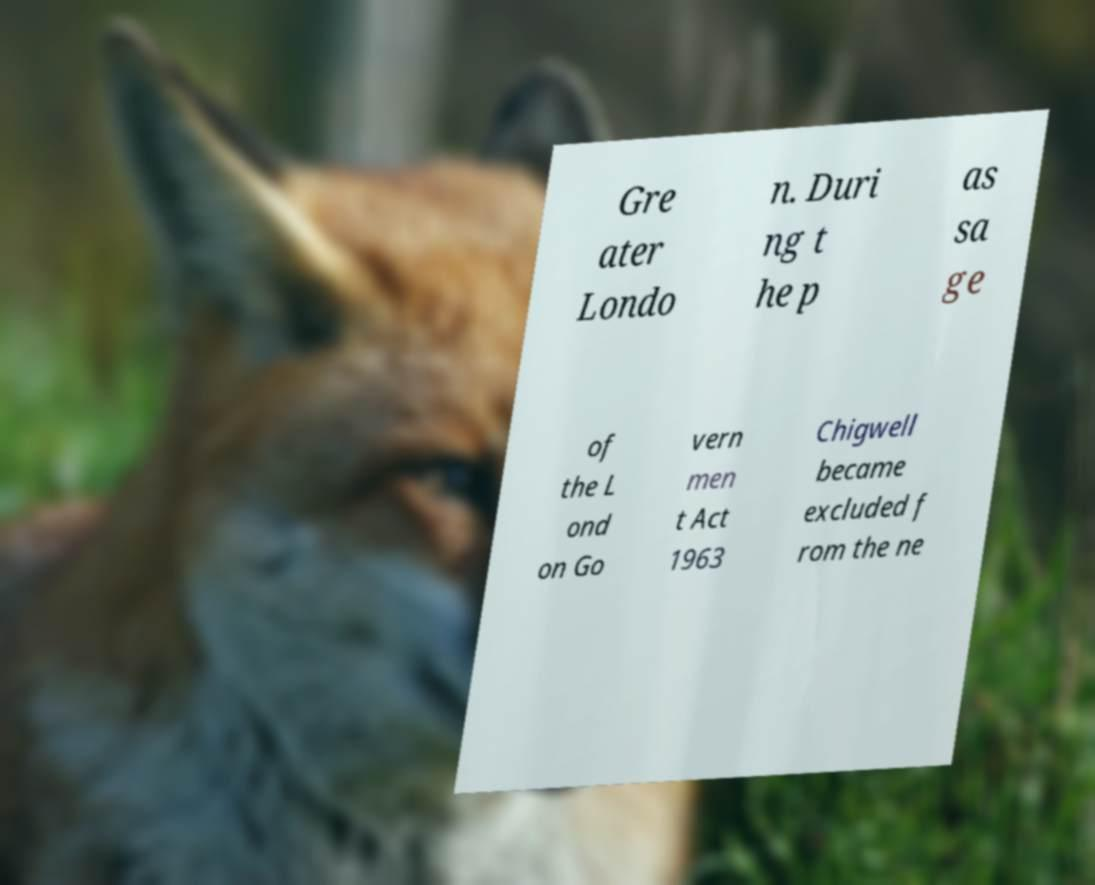There's text embedded in this image that I need extracted. Can you transcribe it verbatim? Gre ater Londo n. Duri ng t he p as sa ge of the L ond on Go vern men t Act 1963 Chigwell became excluded f rom the ne 